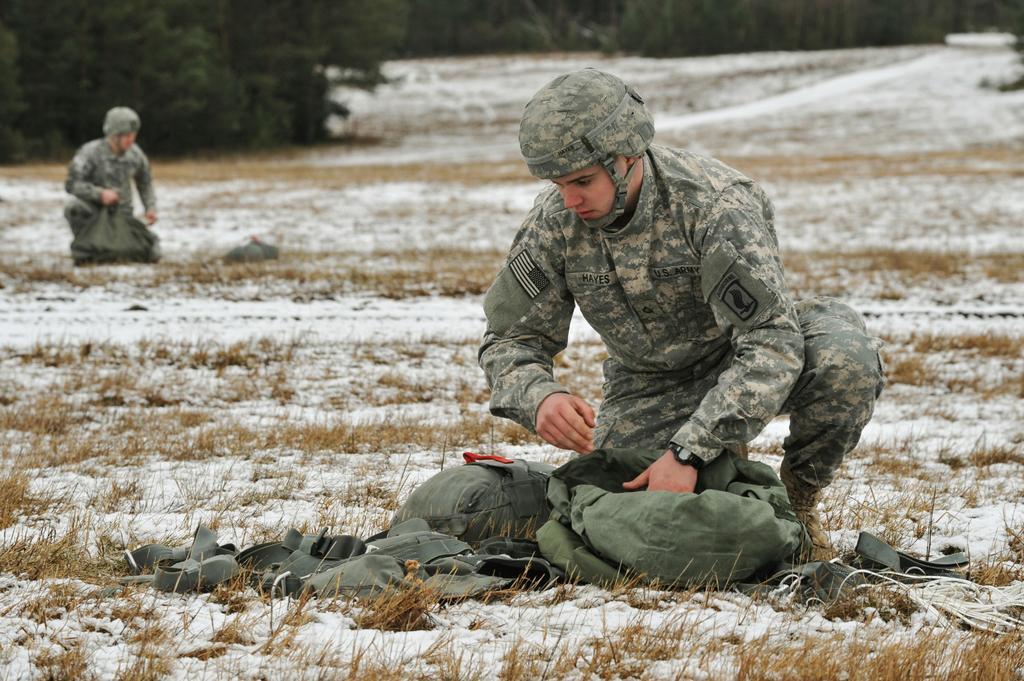How would you summarize this image in a sentence or two? In this image there are two people. In front of them there are a few objects. At the bottom of the image there is snow and grass on the surface. In the background of the image there are trees. 